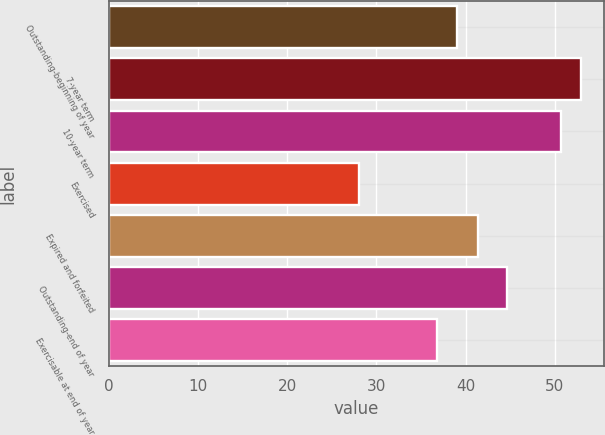Convert chart to OTSL. <chart><loc_0><loc_0><loc_500><loc_500><bar_chart><fcel>Outstanding-beginning of year<fcel>7-year term<fcel>10-year term<fcel>Exercised<fcel>Expired and forfeited<fcel>Outstanding-end of year<fcel>Exercisable at end of year<nl><fcel>39.08<fcel>52.91<fcel>50.64<fcel>28.08<fcel>41.35<fcel>44.64<fcel>36.81<nl></chart> 